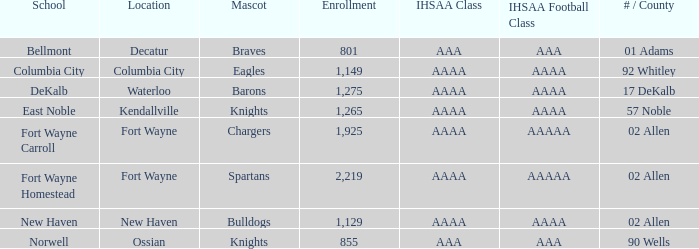What's the ihsaa football division in decatur with an aaa ihsaa group? AAA. 